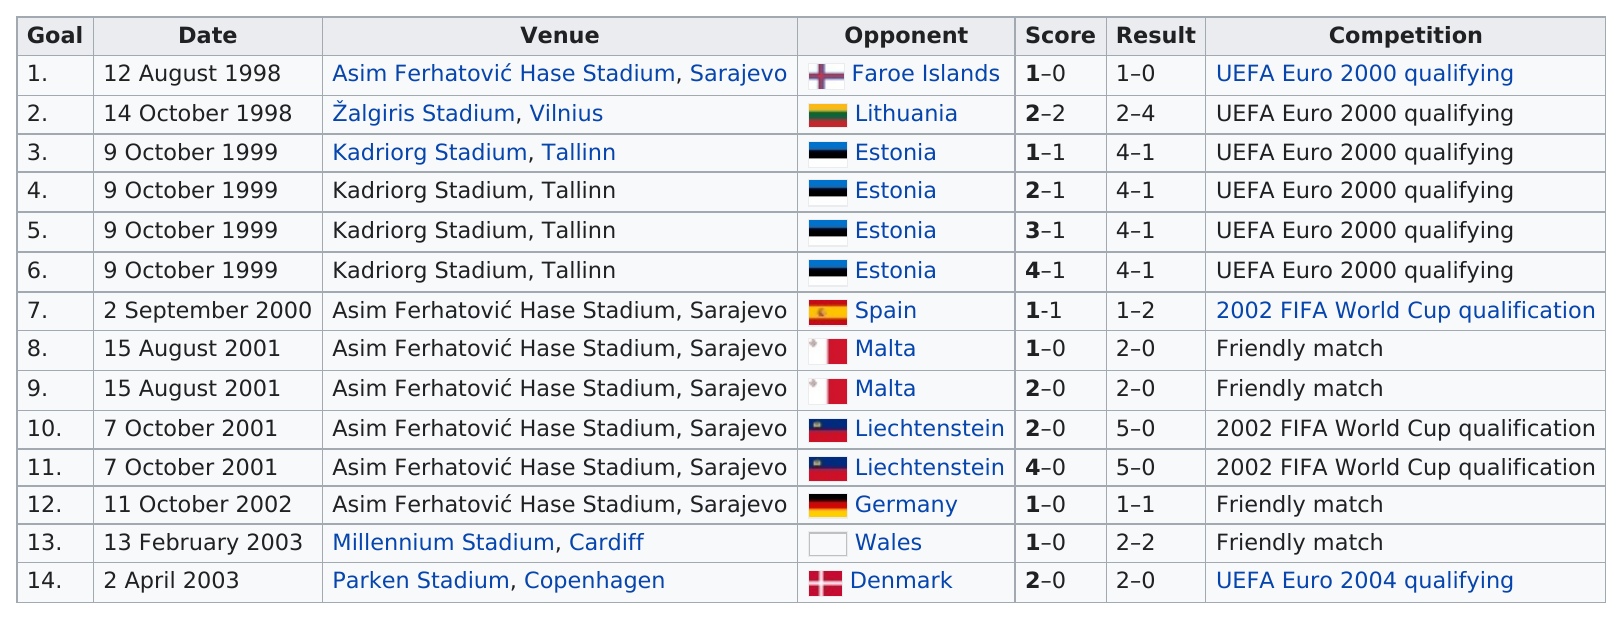Specify some key components in this picture. Baljic played a total of 9 different opponents during their career. The player scored the largest number of goals against Lithuania, despite losing to them. Out of the 10 competitions held, only 1 was not a friendly match. Germany's next opponent in 2002 was Wales. There were a total of 4 friendly matches in the provided table. 